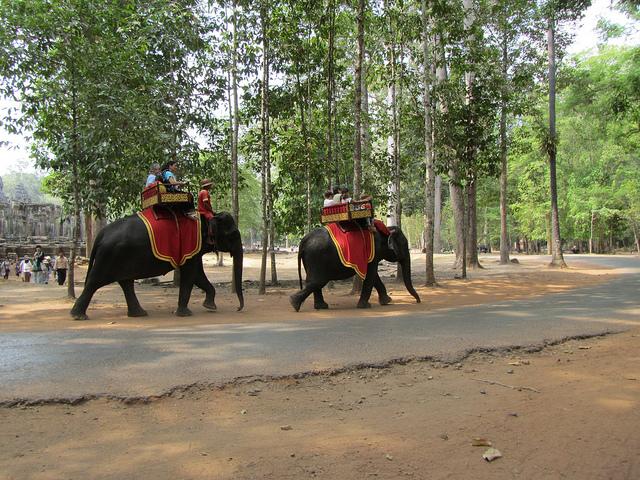What color is the elephants?
Give a very brief answer. Black. What game is the elephant playing with the people?
Short answer required. No game. How many elephants in the picture?
Quick response, please. 2. If the elephants follow the road, which direction will they turn?
Keep it brief. Left. 